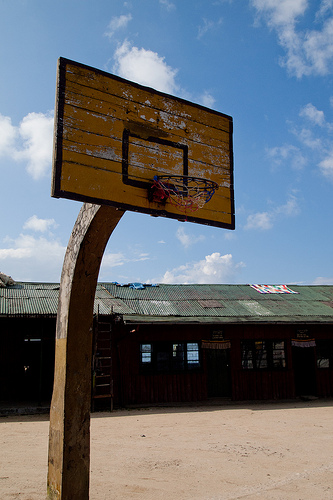<image>
Is the post in front of the roof? Yes. The post is positioned in front of the roof, appearing closer to the camera viewpoint. Is there a goal above the barn? No. The goal is not positioned above the barn. The vertical arrangement shows a different relationship. 